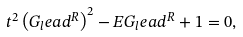<formula> <loc_0><loc_0><loc_500><loc_500>t ^ { 2 } \left ( G _ { l } e a d ^ { R } \right ) ^ { 2 } - E G _ { l } e a d ^ { R } + 1 = 0 ,</formula> 